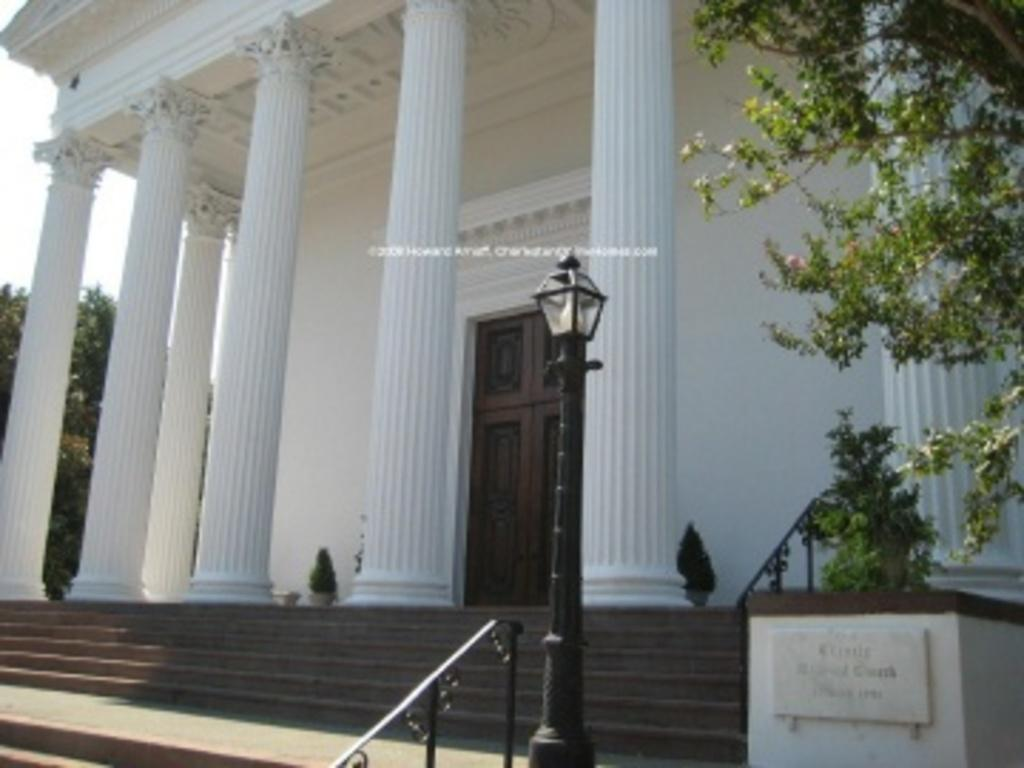What type of structure is visible in the image? There is a building in the image. What is a specific feature of the building? There is a door in the image. Are there any architectural elements supporting the building? Yes, there are pillars in the image. How can one access the building? There are stairs in the image, which may be used to enter the building. Are there any safety features for the stairs? Yes, there are handrails in the image. What is another object visible in the image? There is a light pole in the image. What type of vegetation is present in the image? There are plants and trees in the image. What can be seen in the sky in the image? The sky is visible in the image. What type of beef is being served at the father's barbecue in the image? There is no father or barbecue present in the image; it features a building with various architectural elements and vegetation. What type of rail is used for the stairs in the image? There is no specific mention of the type of rail used for the stairs in the image; only the presence of handrails is noted. 